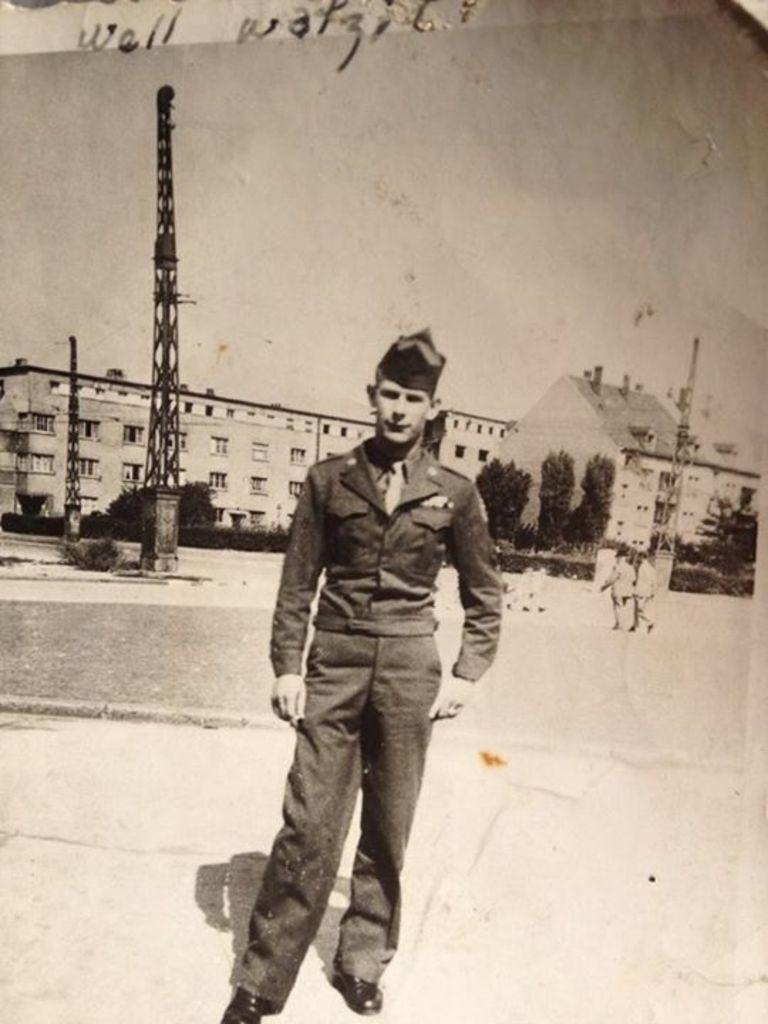Who or what can be seen in the image? There are people in the image. What type of structures are visible in the image? There are buildings and towers in the image. What natural elements can be seen in the image? There are trees and plants in the image. What is visible in the background of the image? The sky is visible in the image. Is there any text present in the image? Yes, there is text on the image. How many chickens are there in the image? There are no chickens present in the image. What color is the tail of the person in the image? There is no mention of a tail on any person in the image, as people do not have tails. 